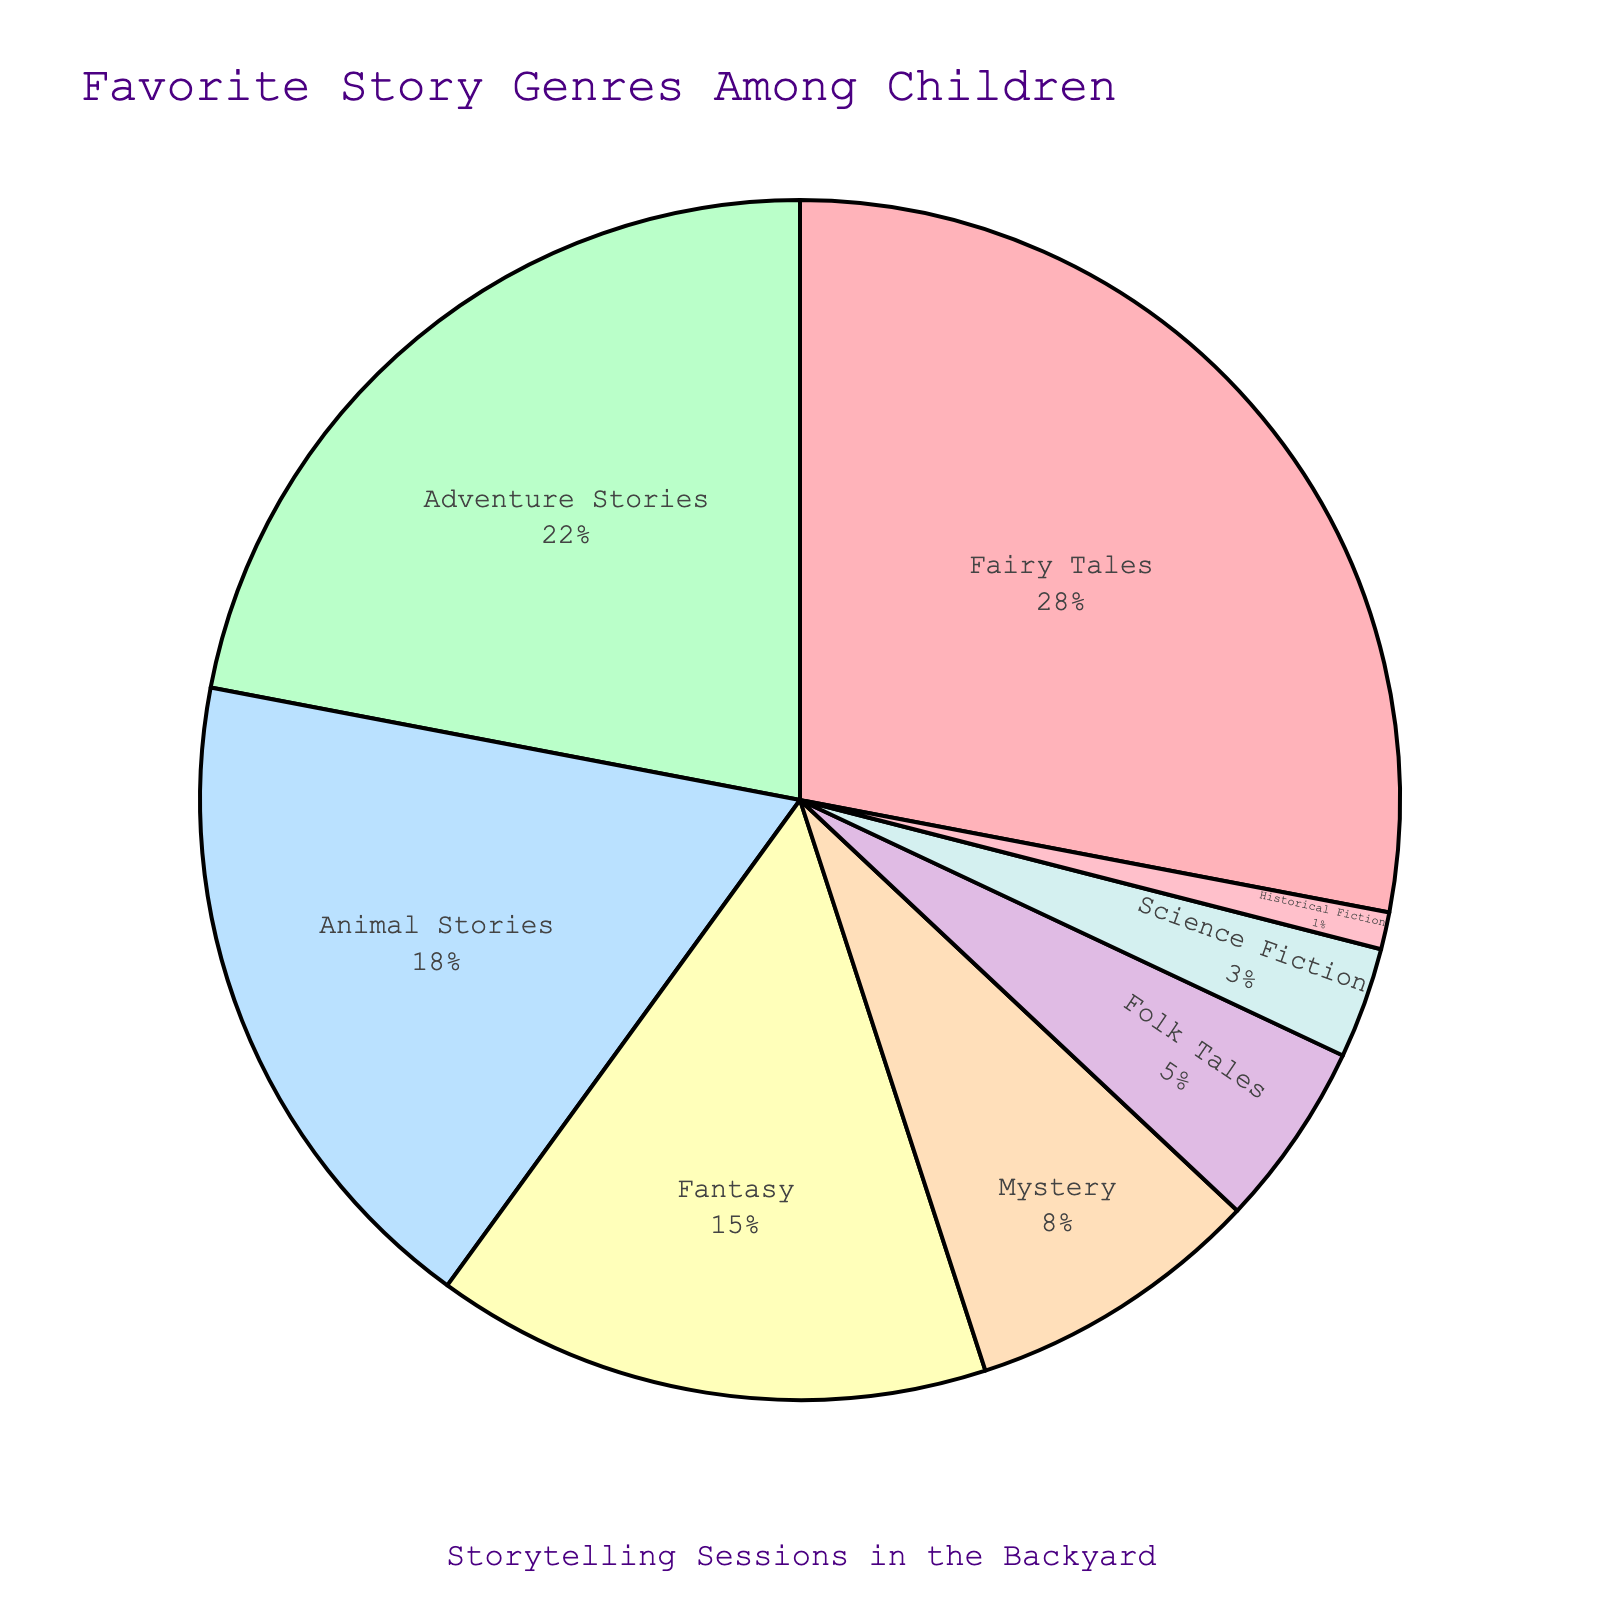Which genre is the most popular among the children? The pie chart shows that 'Fairy Tales' has the highest percentage at 28%, making it the most popular genre.
Answer: Fairy Tales What is the combined percentage of Adventure Stories and Animal Stories? The pie chart indicates that 'Adventure Stories' is 22% and 'Animal Stories' is 18%. Adding these together gives 22% + 18% = 40%.
Answer: 40% How much more popular is Fantasy compared to Historical Fiction? The pie chart shows that 'Fantasy' is 15% and 'Historical Fiction' is 1%. The difference is 15% - 1% = 14%.
Answer: 14% What genres make up more than 20% of the preferred stories? By examining the chart, only 'Fairy Tales' at 28% and 'Adventure Stories' at 22% meet this criterion.
Answer: Fairy Tales, Adventure Stories Which genre is represented by the green slice in the pie chart? The pie chart utilizes a green color for 'Adventure Stories,' which has a percentage of 22%.
Answer: Adventure Stories How does the popularity of Mystery compare to Science Fiction? The pie chart shows 'Mystery' at 8% and 'Science Fiction' at 3%. Comparing these, 'Mystery' is more popular than 'Science Fiction' by 8% - 3% = 5%.
Answer: Mystery is more popular by 5% What is the percentage difference between the least popular and most popular genres? The least popular genre is 'Historical Fiction' at 1%, and the most popular is 'Fairy Tales' at 28%. The difference is 28% - 1% = 27%.
Answer: 27% Which genres collectively make up less than 10% of the preferred stories? The chart shows 'Folk Tales' at 5%, 'Science Fiction' at 3%, and 'Historical Fiction' at 1%. Collectively these add up to 5% + 3% + 1% = 9%, which is less than 10%.
Answer: Folk Tales, Science Fiction, Historical Fiction What is the second most preferred genre among children? The pie chart shows 'Fairy Tales' as the most preferred at 28%. The second most preferred is 'Adventure Stories' at 22%.
Answer: Adventure Stories How does the total popularity of Fantasy and Mystery compare to Fairy Tales? The total percentage of 'Fantasy' and 'Mystery' is 15% + 8% = 23%. 'Fairy Tales' alone is 28%. Comparing these, 'Fairy Tales' is more popular by 28% - 23% = 5%.
Answer: Fairy Tales is more popular by 5% 